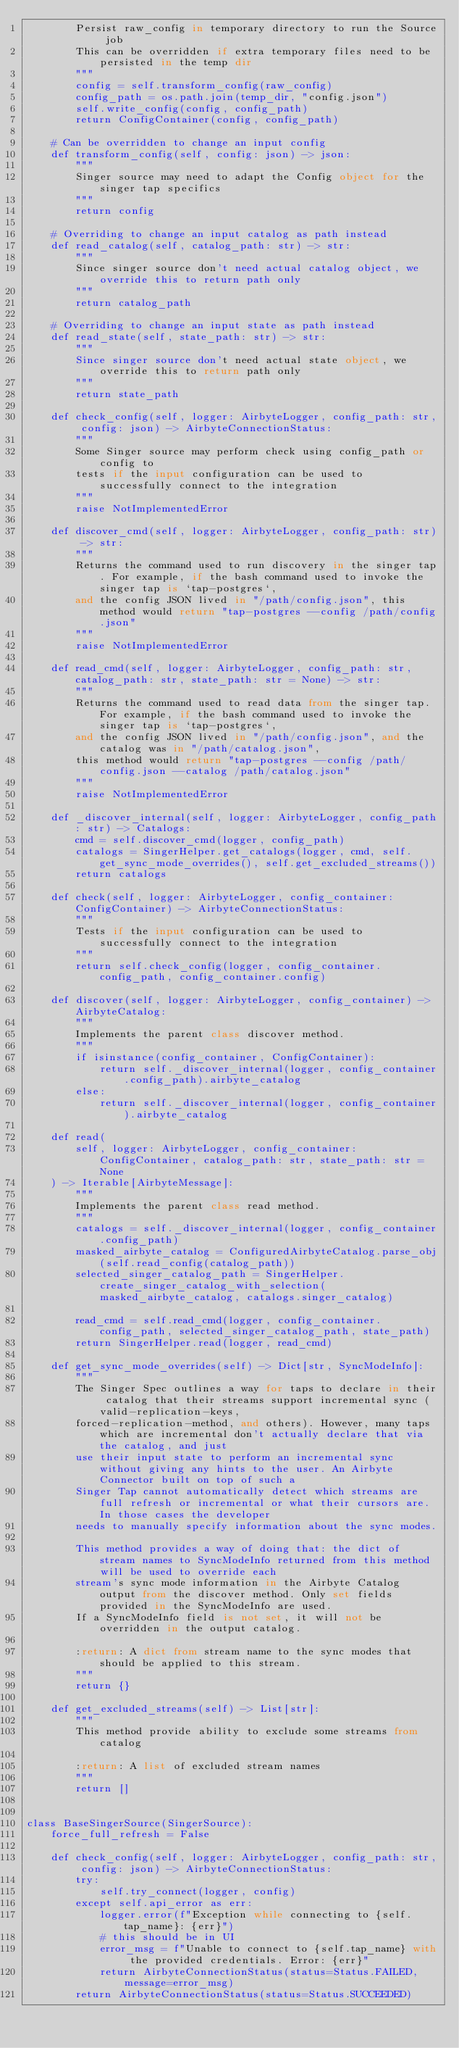Convert code to text. <code><loc_0><loc_0><loc_500><loc_500><_Python_>        Persist raw_config in temporary directory to run the Source job
        This can be overridden if extra temporary files need to be persisted in the temp dir
        """
        config = self.transform_config(raw_config)
        config_path = os.path.join(temp_dir, "config.json")
        self.write_config(config, config_path)
        return ConfigContainer(config, config_path)

    # Can be overridden to change an input config
    def transform_config(self, config: json) -> json:
        """
        Singer source may need to adapt the Config object for the singer tap specifics
        """
        return config

    # Overriding to change an input catalog as path instead
    def read_catalog(self, catalog_path: str) -> str:
        """
        Since singer source don't need actual catalog object, we override this to return path only
        """
        return catalog_path

    # Overriding to change an input state as path instead
    def read_state(self, state_path: str) -> str:
        """
        Since singer source don't need actual state object, we override this to return path only
        """
        return state_path

    def check_config(self, logger: AirbyteLogger, config_path: str, config: json) -> AirbyteConnectionStatus:
        """
        Some Singer source may perform check using config_path or config to
        tests if the input configuration can be used to successfully connect to the integration
        """
        raise NotImplementedError

    def discover_cmd(self, logger: AirbyteLogger, config_path: str) -> str:
        """
        Returns the command used to run discovery in the singer tap. For example, if the bash command used to invoke the singer tap is `tap-postgres`,
        and the config JSON lived in "/path/config.json", this method would return "tap-postgres --config /path/config.json"
        """
        raise NotImplementedError

    def read_cmd(self, logger: AirbyteLogger, config_path: str, catalog_path: str, state_path: str = None) -> str:
        """
        Returns the command used to read data from the singer tap. For example, if the bash command used to invoke the singer tap is `tap-postgres`,
        and the config JSON lived in "/path/config.json", and the catalog was in "/path/catalog.json",
        this method would return "tap-postgres --config /path/config.json --catalog /path/catalog.json"
        """
        raise NotImplementedError

    def _discover_internal(self, logger: AirbyteLogger, config_path: str) -> Catalogs:
        cmd = self.discover_cmd(logger, config_path)
        catalogs = SingerHelper.get_catalogs(logger, cmd, self.get_sync_mode_overrides(), self.get_excluded_streams())
        return catalogs

    def check(self, logger: AirbyteLogger, config_container: ConfigContainer) -> AirbyteConnectionStatus:
        """
        Tests if the input configuration can be used to successfully connect to the integration
        """
        return self.check_config(logger, config_container.config_path, config_container.config)

    def discover(self, logger: AirbyteLogger, config_container) -> AirbyteCatalog:
        """
        Implements the parent class discover method.
        """
        if isinstance(config_container, ConfigContainer):
            return self._discover_internal(logger, config_container.config_path).airbyte_catalog
        else:
            return self._discover_internal(logger, config_container).airbyte_catalog

    def read(
        self, logger: AirbyteLogger, config_container: ConfigContainer, catalog_path: str, state_path: str = None
    ) -> Iterable[AirbyteMessage]:
        """
        Implements the parent class read method.
        """
        catalogs = self._discover_internal(logger, config_container.config_path)
        masked_airbyte_catalog = ConfiguredAirbyteCatalog.parse_obj(self.read_config(catalog_path))
        selected_singer_catalog_path = SingerHelper.create_singer_catalog_with_selection(masked_airbyte_catalog, catalogs.singer_catalog)

        read_cmd = self.read_cmd(logger, config_container.config_path, selected_singer_catalog_path, state_path)
        return SingerHelper.read(logger, read_cmd)

    def get_sync_mode_overrides(self) -> Dict[str, SyncModeInfo]:
        """
        The Singer Spec outlines a way for taps to declare in their catalog that their streams support incremental sync (valid-replication-keys,
        forced-replication-method, and others). However, many taps which are incremental don't actually declare that via the catalog, and just
        use their input state to perform an incremental sync without giving any hints to the user. An Airbyte Connector built on top of such a
        Singer Tap cannot automatically detect which streams are full refresh or incremental or what their cursors are. In those cases the developer
        needs to manually specify information about the sync modes.

        This method provides a way of doing that: the dict of stream names to SyncModeInfo returned from this method will be used to override each
        stream's sync mode information in the Airbyte Catalog output from the discover method. Only set fields provided in the SyncModeInfo are used.
        If a SyncModeInfo field is not set, it will not be overridden in the output catalog.

        :return: A dict from stream name to the sync modes that should be applied to this stream.
        """
        return {}

    def get_excluded_streams(self) -> List[str]:
        """
        This method provide ability to exclude some streams from catalog

        :return: A list of excluded stream names
        """
        return []


class BaseSingerSource(SingerSource):
    force_full_refresh = False

    def check_config(self, logger: AirbyteLogger, config_path: str, config: json) -> AirbyteConnectionStatus:
        try:
            self.try_connect(logger, config)
        except self.api_error as err:
            logger.error(f"Exception while connecting to {self.tap_name}: {err}")
            # this should be in UI
            error_msg = f"Unable to connect to {self.tap_name} with the provided credentials. Error: {err}"
            return AirbyteConnectionStatus(status=Status.FAILED, message=error_msg)
        return AirbyteConnectionStatus(status=Status.SUCCEEDED)
</code> 